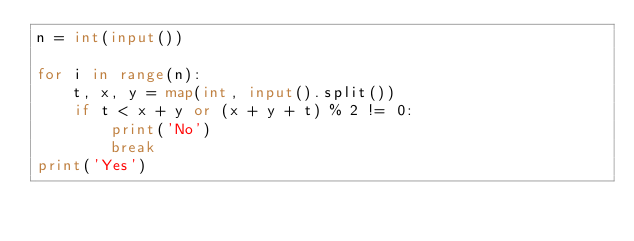Convert code to text. <code><loc_0><loc_0><loc_500><loc_500><_Python_>n = int(input())
 
for i in range(n):
    t, x, y = map(int, input().split())
    if t < x + y or (x + y + t) % 2 != 0:
        print('No')
        break
print('Yes')
</code> 